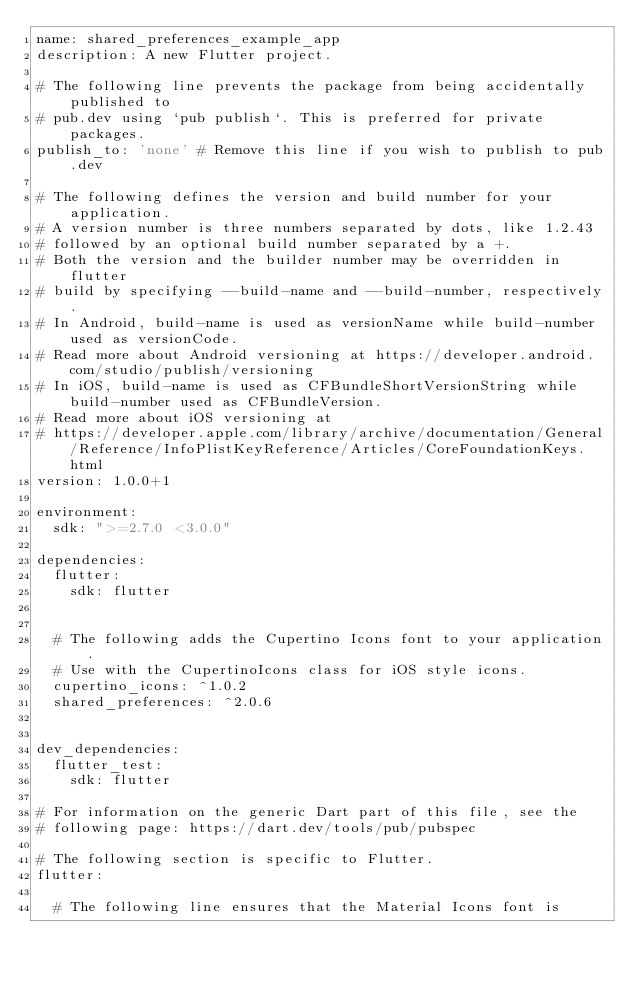<code> <loc_0><loc_0><loc_500><loc_500><_YAML_>name: shared_preferences_example_app
description: A new Flutter project.

# The following line prevents the package from being accidentally published to
# pub.dev using `pub publish`. This is preferred for private packages.
publish_to: 'none' # Remove this line if you wish to publish to pub.dev

# The following defines the version and build number for your application.
# A version number is three numbers separated by dots, like 1.2.43
# followed by an optional build number separated by a +.
# Both the version and the builder number may be overridden in flutter
# build by specifying --build-name and --build-number, respectively.
# In Android, build-name is used as versionName while build-number used as versionCode.
# Read more about Android versioning at https://developer.android.com/studio/publish/versioning
# In iOS, build-name is used as CFBundleShortVersionString while build-number used as CFBundleVersion.
# Read more about iOS versioning at
# https://developer.apple.com/library/archive/documentation/General/Reference/InfoPlistKeyReference/Articles/CoreFoundationKeys.html
version: 1.0.0+1

environment:
  sdk: ">=2.7.0 <3.0.0"

dependencies:
  flutter:
    sdk: flutter


  # The following adds the Cupertino Icons font to your application.
  # Use with the CupertinoIcons class for iOS style icons.
  cupertino_icons: ^1.0.2
  shared_preferences: ^2.0.6
  

dev_dependencies:
  flutter_test:
    sdk: flutter

# For information on the generic Dart part of this file, see the
# following page: https://dart.dev/tools/pub/pubspec

# The following section is specific to Flutter.
flutter:

  # The following line ensures that the Material Icons font is</code> 